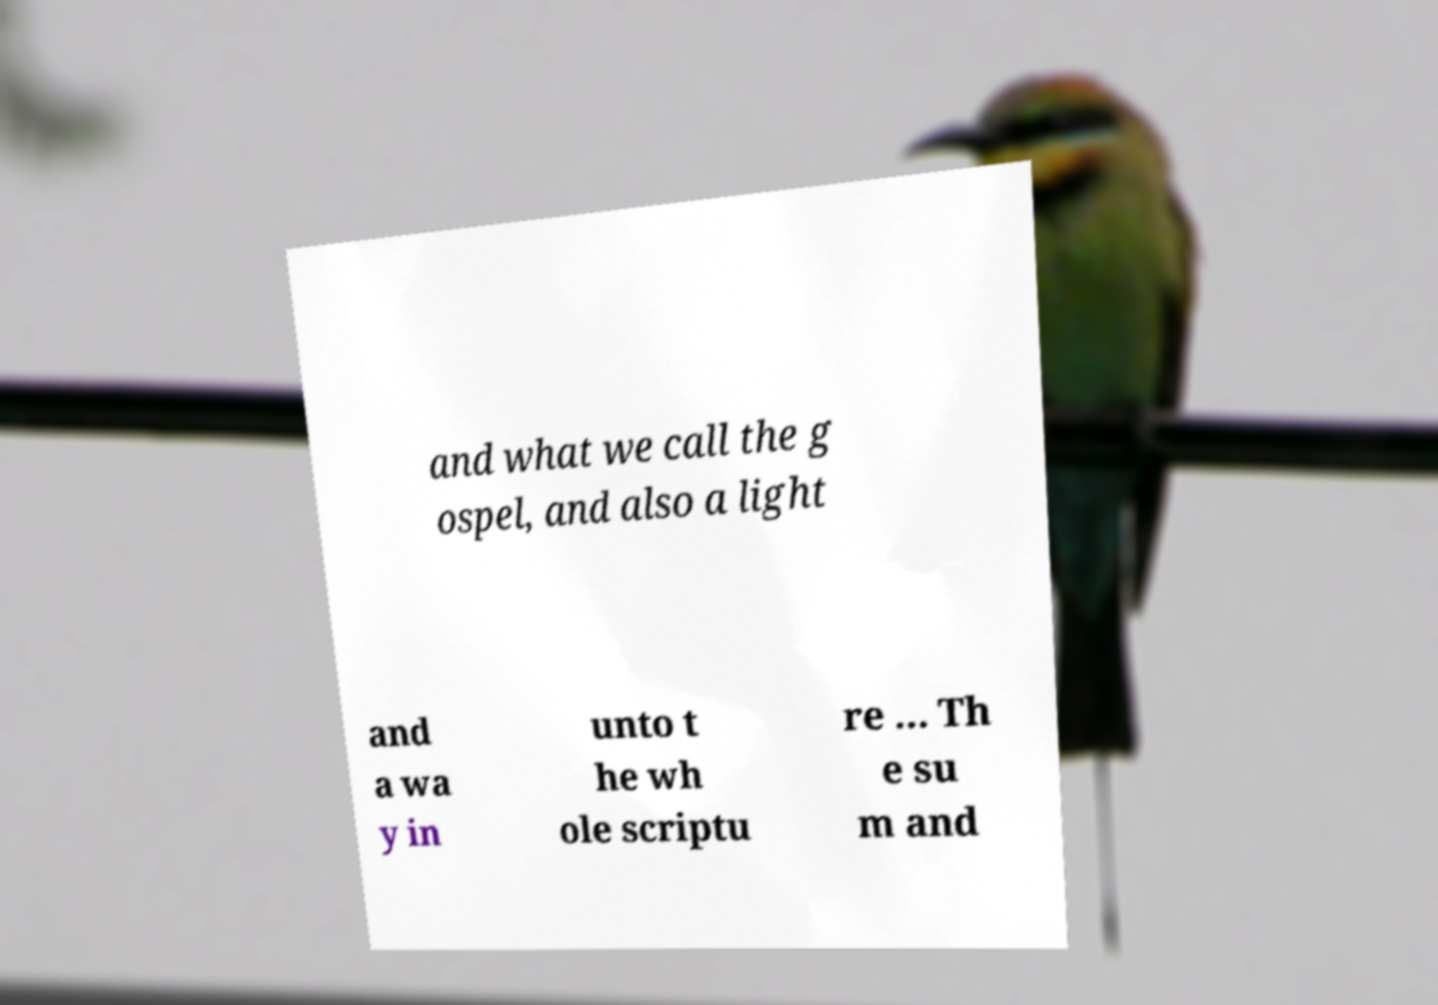Can you accurately transcribe the text from the provided image for me? and what we call the g ospel, and also a light and a wa y in unto t he wh ole scriptu re ... Th e su m and 